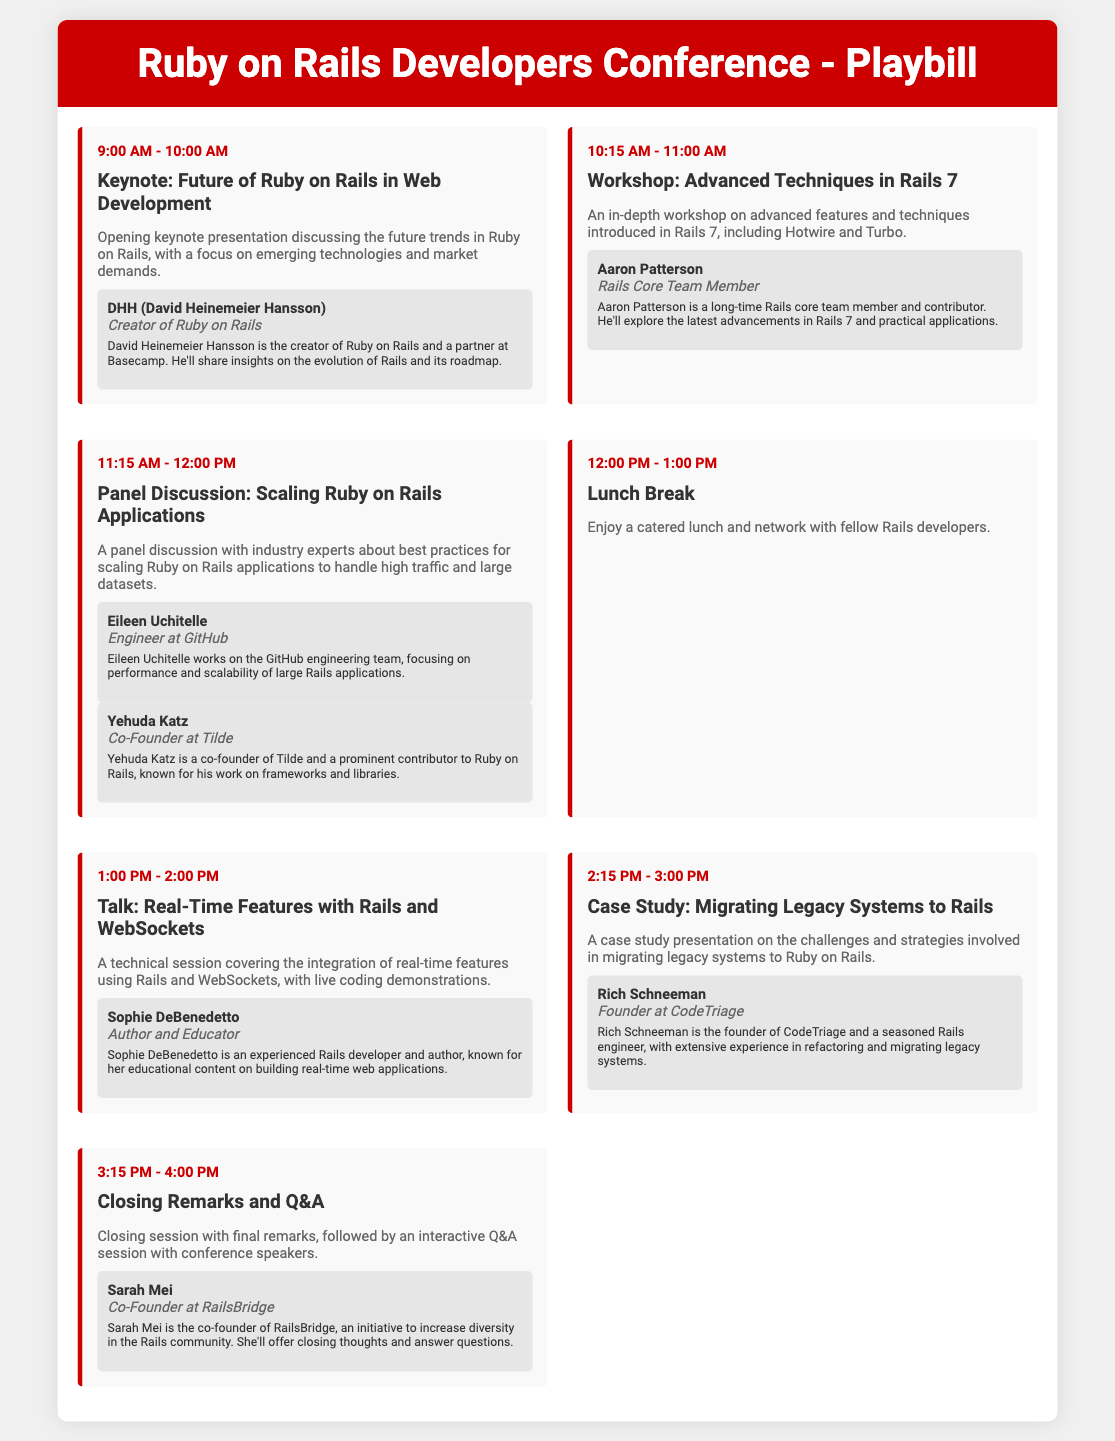what time does the keynote start? The keynote starts at 9:00 AM as indicated in the agenda.
Answer: 9:00 AM who is the speaker for the workshop on Rails 7? The speaker for the workshop on Rails 7 is Aaron Patterson, mentioned in the event details.
Answer: Aaron Patterson how long is the lunch break scheduled for? The lunch break is scheduled for one hour, as noted in the agenda section.
Answer: 1 hour what is the title of the closing session? The title of the closing session is "Closing Remarks and Q&A", as shown in the agenda.
Answer: Closing Remarks and Q&A which speaker is associated with GitHub? Eileen Uchitelle, mentioned in the panel discussion event, is associated with GitHub.
Answer: Eileen Uchitelle how many speakers are listed in the panel discussion? There are two speakers listed in the panel discussion event, Eileen Uchitelle and Yehuda Katz.
Answer: 2 speakers what topic does the case study presentation cover? The case study presentation covers the topic of "Migrating Legacy Systems to Rails", as detailed in the agenda.
Answer: Migrating Legacy Systems to Rails which event includes live coding demonstrations? The event that includes live coding demonstrations is titled "Talk: Real-Time Features with Rails and WebSockets".
Answer: Talk: Real-Time Features with Rails and WebSockets who is the creator of Ruby on Rails? The creator of Ruby on Rails is David Heinemeier Hansson, mentioned in the keynote section.
Answer: David Heinemeier Hansson 